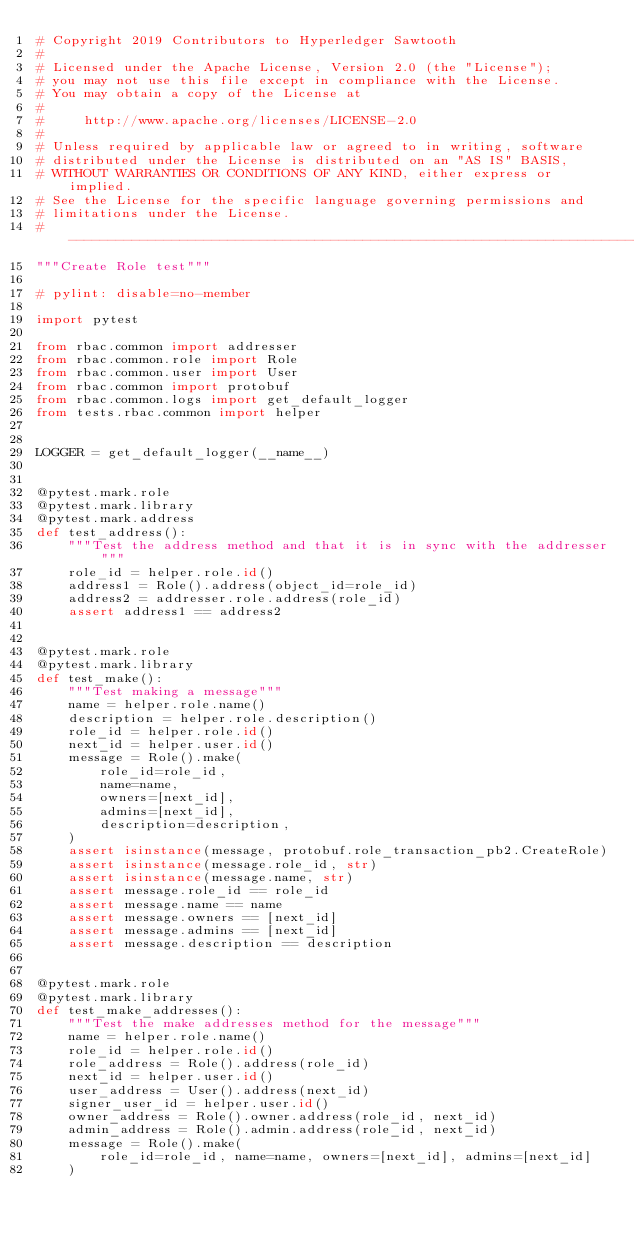<code> <loc_0><loc_0><loc_500><loc_500><_Python_># Copyright 2019 Contributors to Hyperledger Sawtooth
#
# Licensed under the Apache License, Version 2.0 (the "License");
# you may not use this file except in compliance with the License.
# You may obtain a copy of the License at
#
#     http://www.apache.org/licenses/LICENSE-2.0
#
# Unless required by applicable law or agreed to in writing, software
# distributed under the License is distributed on an "AS IS" BASIS,
# WITHOUT WARRANTIES OR CONDITIONS OF ANY KIND, either express or implied.
# See the License for the specific language governing permissions and
# limitations under the License.
# -----------------------------------------------------------------------------
"""Create Role test"""

# pylint: disable=no-member

import pytest

from rbac.common import addresser
from rbac.common.role import Role
from rbac.common.user import User
from rbac.common import protobuf
from rbac.common.logs import get_default_logger
from tests.rbac.common import helper


LOGGER = get_default_logger(__name__)


@pytest.mark.role
@pytest.mark.library
@pytest.mark.address
def test_address():
    """Test the address method and that it is in sync with the addresser"""
    role_id = helper.role.id()
    address1 = Role().address(object_id=role_id)
    address2 = addresser.role.address(role_id)
    assert address1 == address2


@pytest.mark.role
@pytest.mark.library
def test_make():
    """Test making a message"""
    name = helper.role.name()
    description = helper.role.description()
    role_id = helper.role.id()
    next_id = helper.user.id()
    message = Role().make(
        role_id=role_id,
        name=name,
        owners=[next_id],
        admins=[next_id],
        description=description,
    )
    assert isinstance(message, protobuf.role_transaction_pb2.CreateRole)
    assert isinstance(message.role_id, str)
    assert isinstance(message.name, str)
    assert message.role_id == role_id
    assert message.name == name
    assert message.owners == [next_id]
    assert message.admins == [next_id]
    assert message.description == description


@pytest.mark.role
@pytest.mark.library
def test_make_addresses():
    """Test the make addresses method for the message"""
    name = helper.role.name()
    role_id = helper.role.id()
    role_address = Role().address(role_id)
    next_id = helper.user.id()
    user_address = User().address(next_id)
    signer_user_id = helper.user.id()
    owner_address = Role().owner.address(role_id, next_id)
    admin_address = Role().admin.address(role_id, next_id)
    message = Role().make(
        role_id=role_id, name=name, owners=[next_id], admins=[next_id]
    )
</code> 